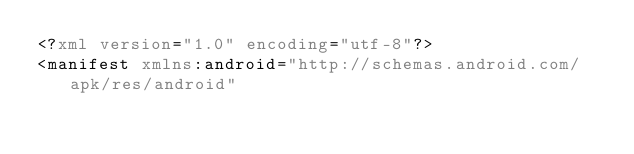<code> <loc_0><loc_0><loc_500><loc_500><_XML_><?xml version="1.0" encoding="utf-8"?>
<manifest xmlns:android="http://schemas.android.com/apk/res/android"</code> 